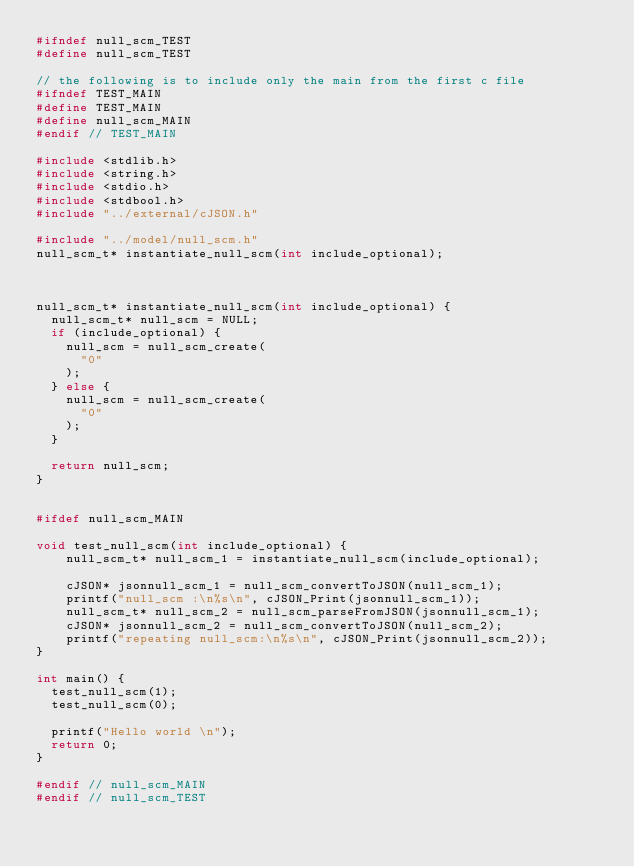<code> <loc_0><loc_0><loc_500><loc_500><_C_>#ifndef null_scm_TEST
#define null_scm_TEST

// the following is to include only the main from the first c file
#ifndef TEST_MAIN
#define TEST_MAIN
#define null_scm_MAIN
#endif // TEST_MAIN

#include <stdlib.h>
#include <string.h>
#include <stdio.h>
#include <stdbool.h>
#include "../external/cJSON.h"

#include "../model/null_scm.h"
null_scm_t* instantiate_null_scm(int include_optional);



null_scm_t* instantiate_null_scm(int include_optional) {
  null_scm_t* null_scm = NULL;
  if (include_optional) {
    null_scm = null_scm_create(
      "0"
    );
  } else {
    null_scm = null_scm_create(
      "0"
    );
  }

  return null_scm;
}


#ifdef null_scm_MAIN

void test_null_scm(int include_optional) {
    null_scm_t* null_scm_1 = instantiate_null_scm(include_optional);

	cJSON* jsonnull_scm_1 = null_scm_convertToJSON(null_scm_1);
	printf("null_scm :\n%s\n", cJSON_Print(jsonnull_scm_1));
	null_scm_t* null_scm_2 = null_scm_parseFromJSON(jsonnull_scm_1);
	cJSON* jsonnull_scm_2 = null_scm_convertToJSON(null_scm_2);
	printf("repeating null_scm:\n%s\n", cJSON_Print(jsonnull_scm_2));
}

int main() {
  test_null_scm(1);
  test_null_scm(0);

  printf("Hello world \n");
  return 0;
}

#endif // null_scm_MAIN
#endif // null_scm_TEST
</code> 